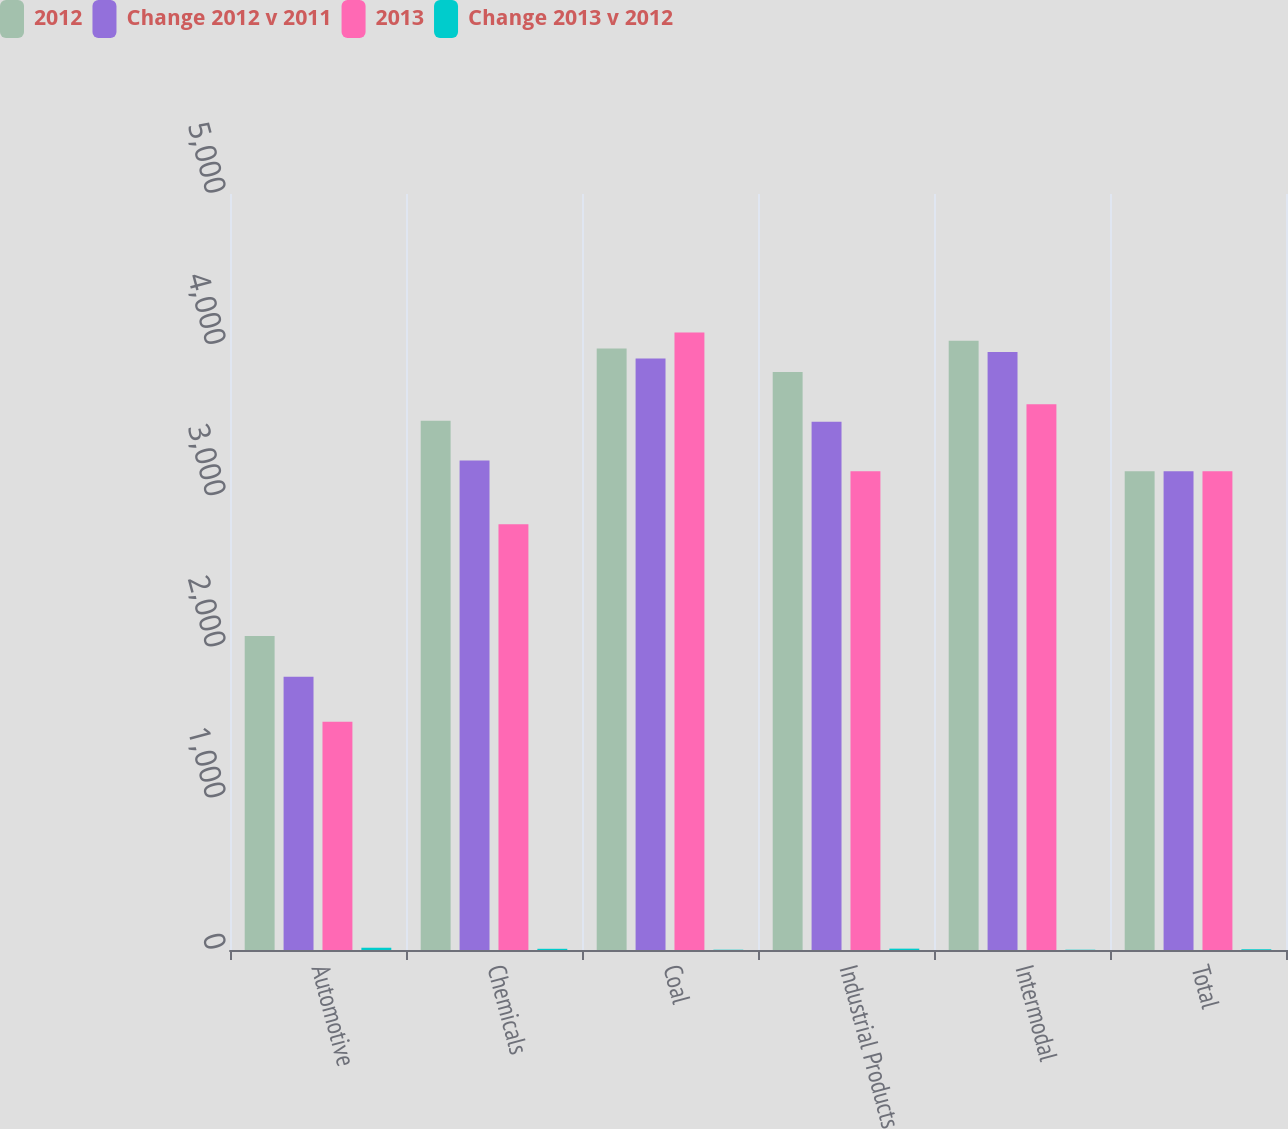<chart> <loc_0><loc_0><loc_500><loc_500><stacked_bar_chart><ecel><fcel>Automotive<fcel>Chemicals<fcel>Coal<fcel>Industrial Products<fcel>Intermodal<fcel>Total<nl><fcel>2012<fcel>2077<fcel>3501<fcel>3978<fcel>3822<fcel>4030<fcel>3166<nl><fcel>Change 2012 v 2011<fcel>1807<fcel>3238<fcel>3912<fcel>3494<fcel>3955<fcel>3166<nl><fcel>2013<fcel>1510<fcel>2815<fcel>4084<fcel>3166<fcel>3609<fcel>3166<nl><fcel>Change 2013 v 2012<fcel>15<fcel>8<fcel>2<fcel>9<fcel>2<fcel>5<nl></chart> 